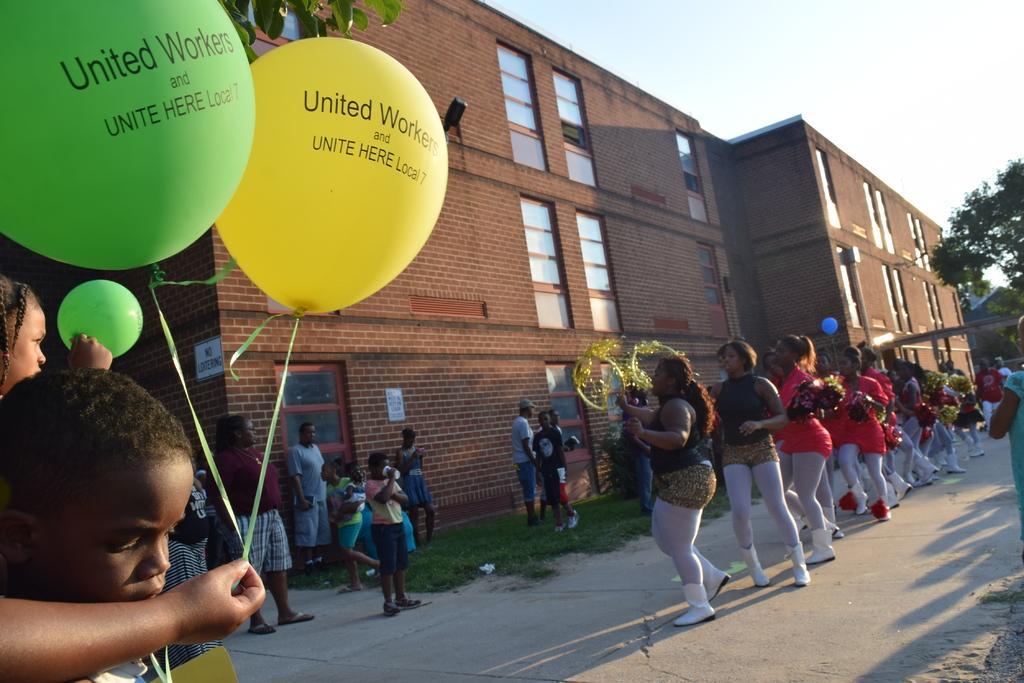Please provide a concise description of this image. In the picture we can see a building with the windows and near it, we can see few women are standing in the different costumes and a person is holding two balloons and in the background we can see a part of the sky. 